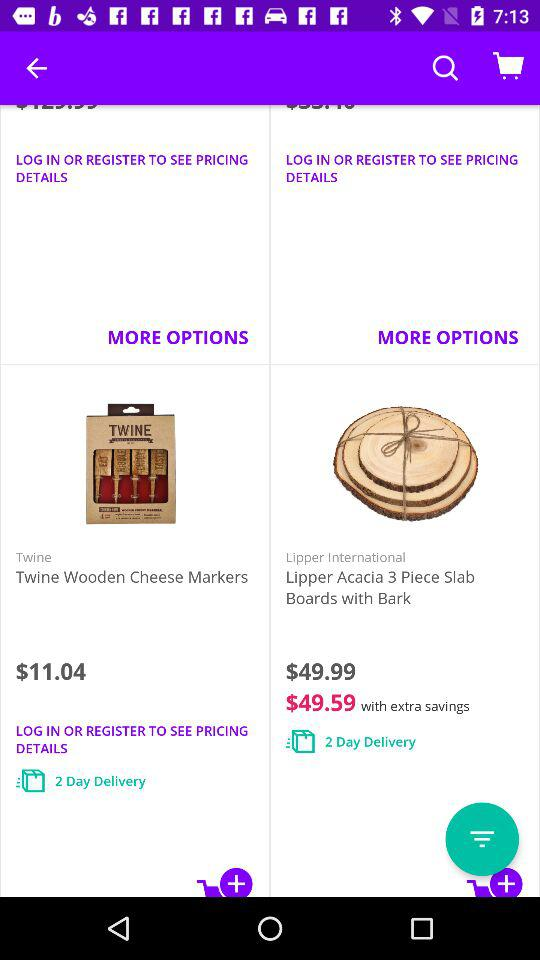Which item is cheaper, the Twine Wooden Cheese Markers or the Lipper Acacia 3 Piece Slab Boards with Bark?
Answer the question using a single word or phrase. Twine Wooden Cheese Markers 